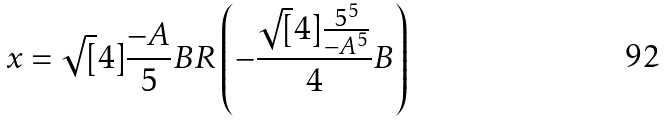Convert formula to latex. <formula><loc_0><loc_0><loc_500><loc_500>x = \sqrt { [ } 4 ] { \frac { - A } { 5 } } B R \left ( - \frac { \sqrt { [ } 4 ] { \frac { 5 ^ { 5 } } { - A ^ { 5 } } } } { 4 } B \right )</formula> 